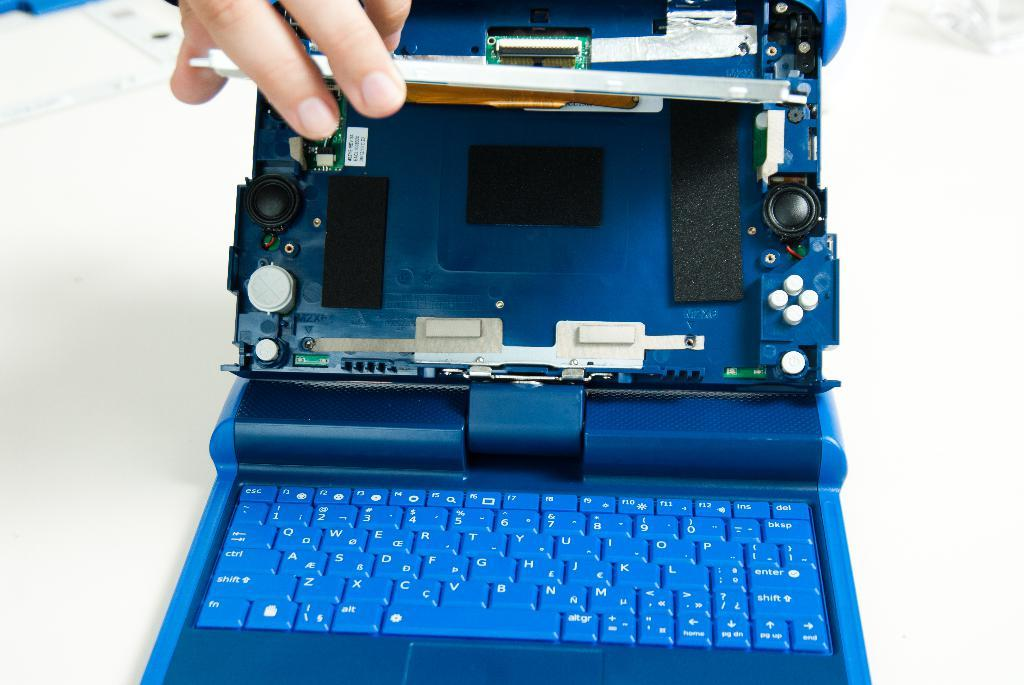Provide a one-sentence caption for the provided image. Blue laptop with the screen removed and a tiny sticker inside that says "3ZYE REV 34". 